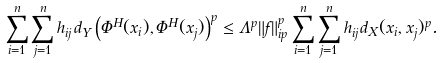Convert formula to latex. <formula><loc_0><loc_0><loc_500><loc_500>\sum _ { i = 1 } ^ { n } \sum _ { j = 1 } ^ { n } h _ { i j } d _ { Y } \left ( \Phi ^ { H } ( x _ { i } ) , \Phi ^ { H } ( x _ { j } ) \right ) ^ { p } \leq \Lambda ^ { p } \| f \| _ { \L i p } ^ { p } \sum _ { i = 1 } ^ { n } \sum _ { j = 1 } ^ { n } h _ { i j } d _ { X } ( x _ { i } , x _ { j } ) ^ { p } .</formula> 